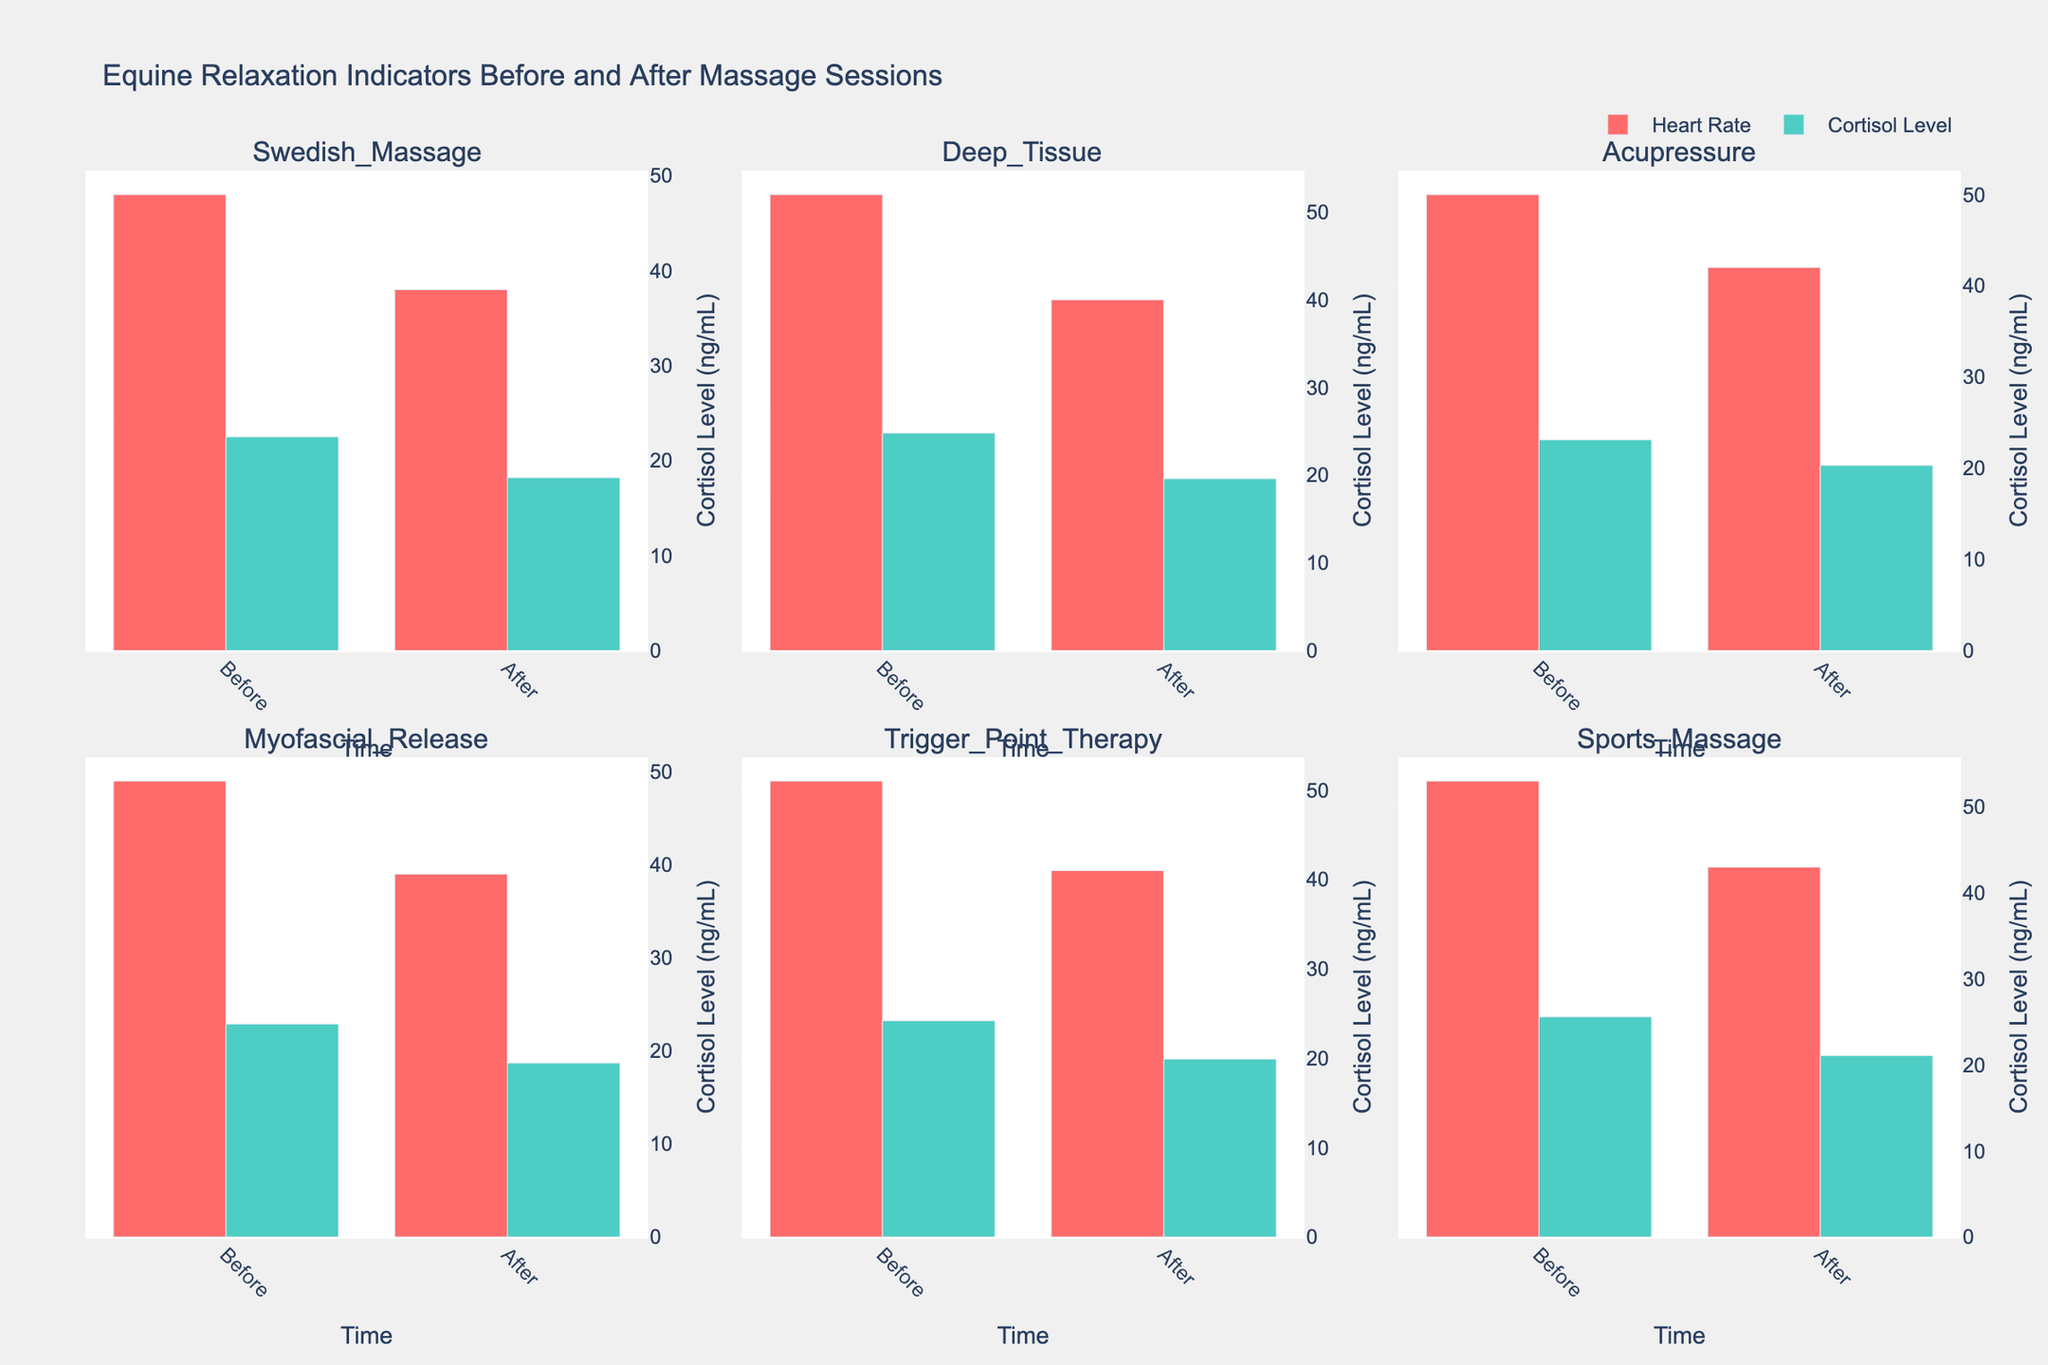What is the title of the figure? Look at the top of the figure, where titles are usually displayed, to find the main subject being addressed.
Answer: Equine Relaxation Indicators Before and After Massage Sessions How does the horse's heart rate change after Swedish Massage? Find the subplot titled 'Swedish Massage'. Compare the heart rate bar height before and after the massage to determine the change.
Answer: It decreases Among all the treatments, which one shows the highest heart rate before treatment? Look across all subplots at the 'Before' heart rate bars and identify the highest value.
Answer: Sports Massage Which treatment leads to the largest decrease in cortisol level? For each subplot, calculate the difference in cortisol level before and after treatment, then identify the treatment with the largest decrease.
Answer: Sports Massage What is the average heart rate after treatment for all the massages listed? Consider the 'After' heart rate for each treatment: (38 + 40 + 42 + 39 + 41 + 43). Calculate the average by summing these values and dividing by the number of treatments.
Answer: 40.5 How does acupressure affect cortisol levels in horses? Reference the 'Acupressure' subplot and compare the cortisol levels before and after the massage.
Answer: It decreases Compare the heart rate reduction of Trigger Point Therapy to Deep Tissue Massage. Which one is greater? From the corresponding subplots, calculate the reduction in heart rate for both treatments (Before - After) and compare the results.
Answer: Deep Tissue Massage Which treatment results in the lowest cortisol level after treatment? Examine the 'After' cortisol levels across all subplots and find the smallest value.
Answer: Swedish Massage Is there a treatment that increases the heart rate after the session? Check all treatments subplots for 'After' values exceeding 'Before' values in heart rate.
Answer: No How many different treatments are compared in the figure? Count the number of unique subplot titles.
Answer: 6 